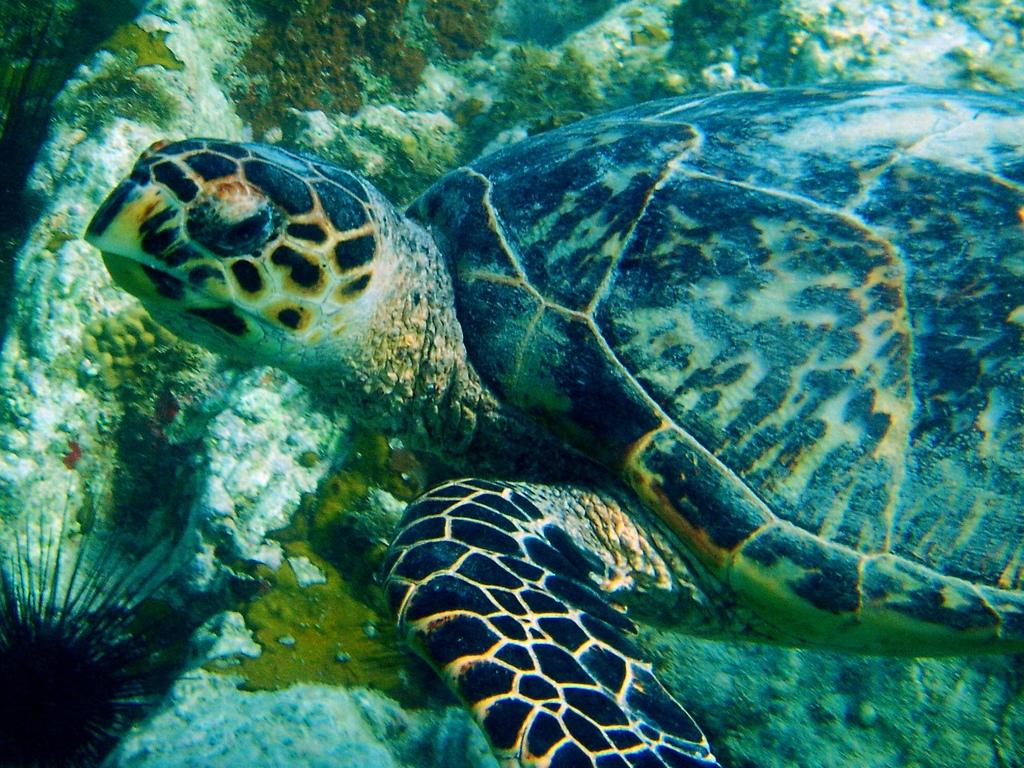What type of animal is in the image? There is a tortoise in the image. Where is the tortoise located in the image? The tortoise is in the water. What type of fruit is hanging from the tree in the image? There is no tree or fruit present in the image; it features a tortoise in the water. 